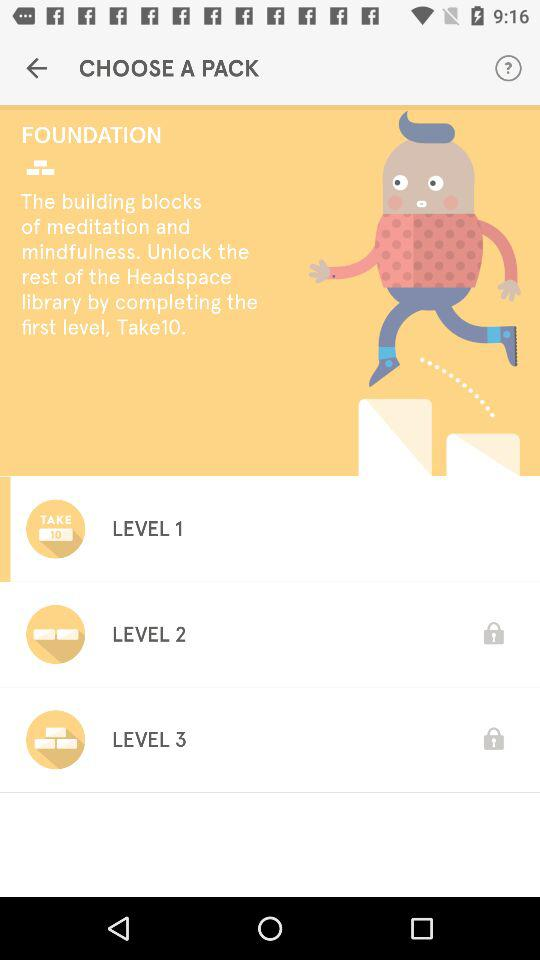How many levels are locked in the Foundation pack?
Answer the question using a single word or phrase. 2 